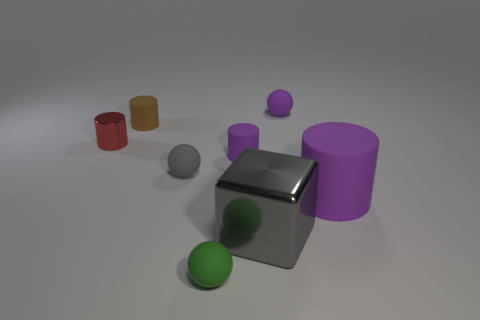Subtract all small shiny cylinders. How many cylinders are left? 3 Subtract all spheres. How many objects are left? 5 Subtract 2 spheres. How many spheres are left? 1 Add 1 rubber spheres. How many objects exist? 9 Subtract all yellow cubes. Subtract all yellow cylinders. How many cubes are left? 1 Subtract all cyan cylinders. How many yellow blocks are left? 0 Subtract all purple cylinders. Subtract all spheres. How many objects are left? 3 Add 8 small green things. How many small green things are left? 9 Add 2 small yellow metallic things. How many small yellow metallic things exist? 2 Subtract all green balls. How many balls are left? 2 